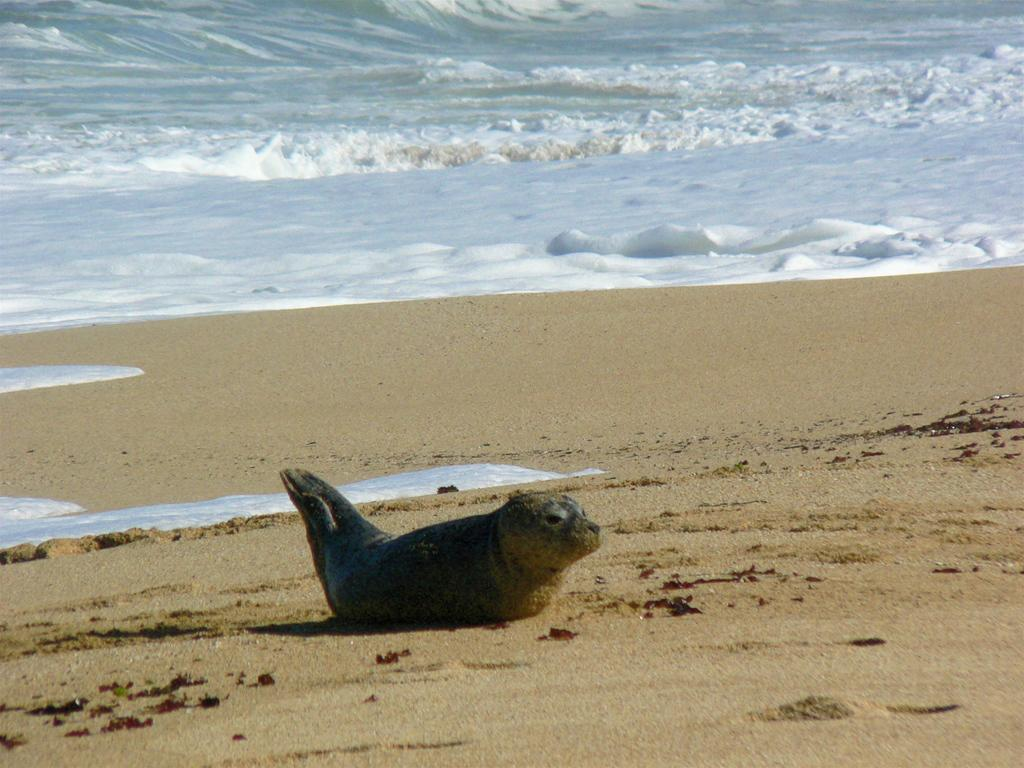What animal is present in the image? There is a seal in the image. What type of terrain is the seal resting on? The seal is on a sandy land. What can be seen in the distance behind the seal? There is a sea visible in the background of the image. What type of planes can be seen flying over the seal in the image? There are no planes visible in the image; it only features a seal on sandy land with a sea in the background. 